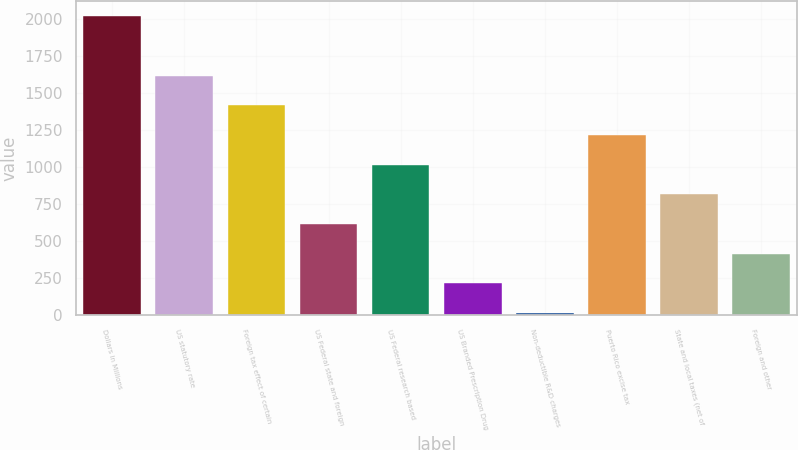Convert chart. <chart><loc_0><loc_0><loc_500><loc_500><bar_chart><fcel>Dollars in Millions<fcel>US statutory rate<fcel>Foreign tax effect of certain<fcel>US Federal state and foreign<fcel>US Federal research based<fcel>US Branded Prescription Drug<fcel>Non-deductible R&D charges<fcel>Puerto Rico excise tax<fcel>State and local taxes (net of<fcel>Foreign and other<nl><fcel>2018<fcel>1617.8<fcel>1417.7<fcel>617.3<fcel>1017.5<fcel>217.1<fcel>17<fcel>1217.6<fcel>817.4<fcel>417.2<nl></chart> 